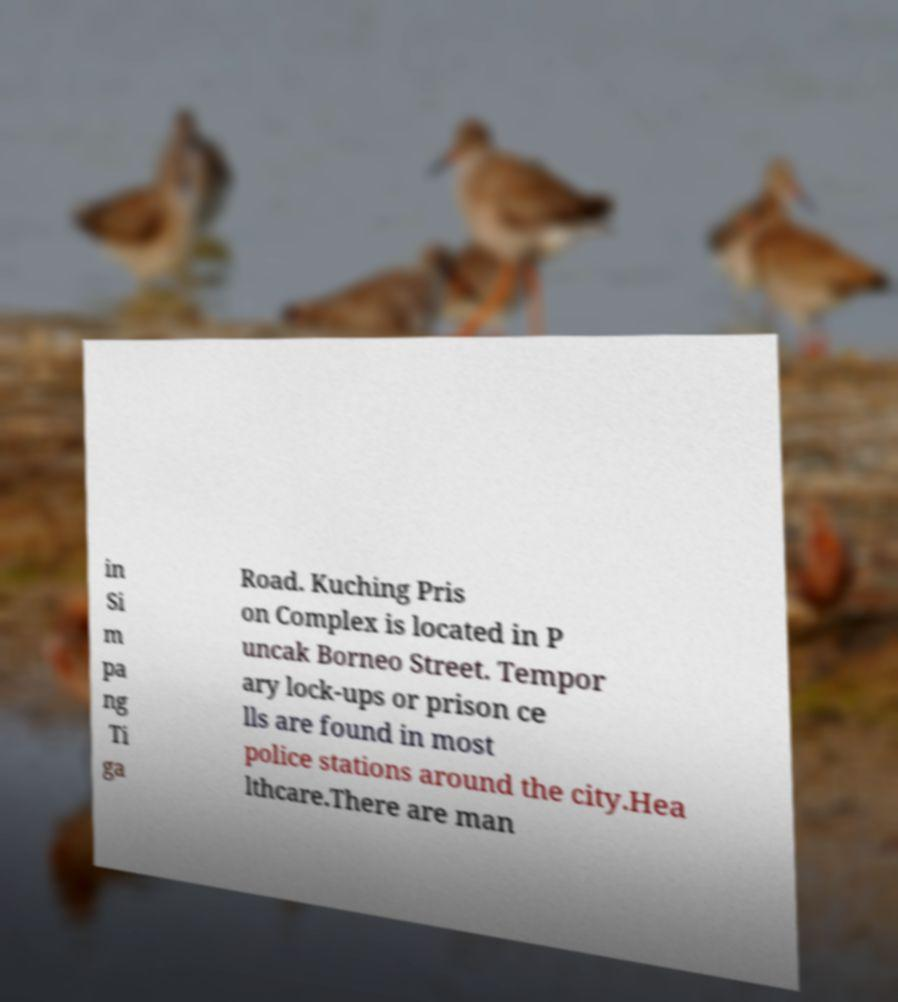What messages or text are displayed in this image? I need them in a readable, typed format. in Si m pa ng Ti ga Road. Kuching Pris on Complex is located in P uncak Borneo Street. Tempor ary lock-ups or prison ce lls are found in most police stations around the city.Hea lthcare.There are man 